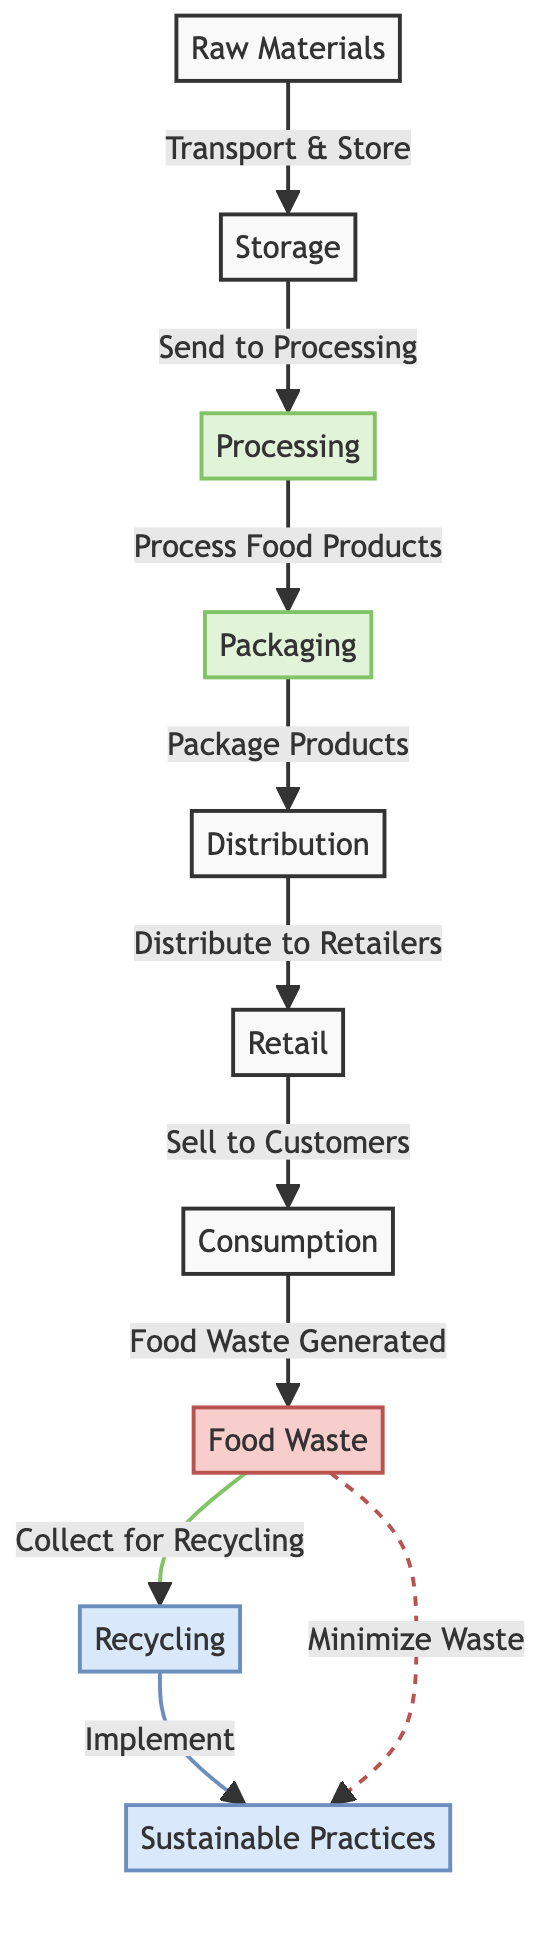What is the first step in the food chain? The process starts from 'Raw Materials' which is the initial step in the flow.
Answer: Raw Materials How many nodes are present in the diagram? To find the number of nodes, we can count each distinct element in the diagram. There are a total of 9 nodes.
Answer: 9 What type of waste is generated during the consumption phase? The specific waste generated is indicated as 'Food Waste' in the diagram.
Answer: Food Waste What happens to food waste after it is collected? After food waste is collected, it is directed towards 'Recycling' as shown by the flow in the diagram.
Answer: Recycling Which node follows the 'Processing' node? The node that follows 'Processing' is 'Packaging', which is the next step in the flow.
Answer: Packaging How does 'Food Waste' connect to 'Sustainable Practices'? 'Food Waste' has a direct flow towards 'Recycling', and it also minimizes waste while connecting to 'Sustainable Practices' in a dashed line that represents a secondary relationship.
Answer: By recycling and minimizing waste What phase involves selling to customers? The 'Retail' phase is where products are sold to customers as per the diagram's flow.
Answer: Retail What two actions are taken after food waste is generated? Food waste is both collected for recycling and minimized to support sustainable practices.
Answer: Collect for Recycling and Minimize Waste Which node comes before 'Storage'? The 'Raw Materials' node is listed before 'Storage' in the sequence, indicating it's the initial step.
Answer: Raw Materials 